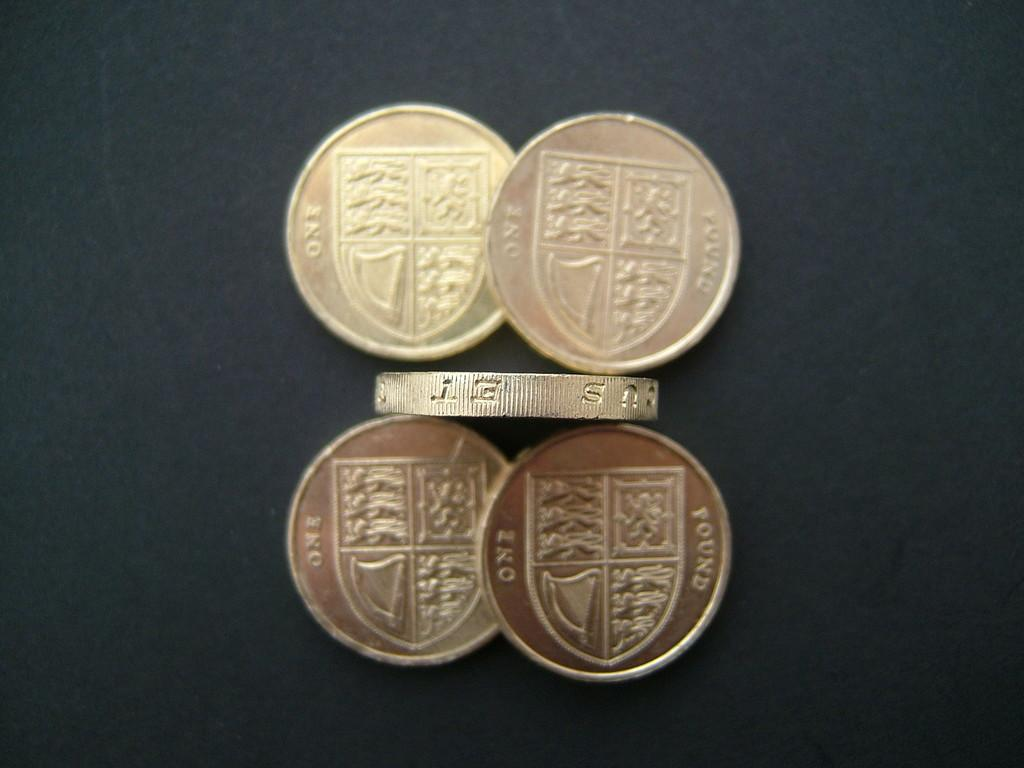<image>
Create a compact narrative representing the image presented. A coin standing on its edge has the letters E and T on the rim of it. 